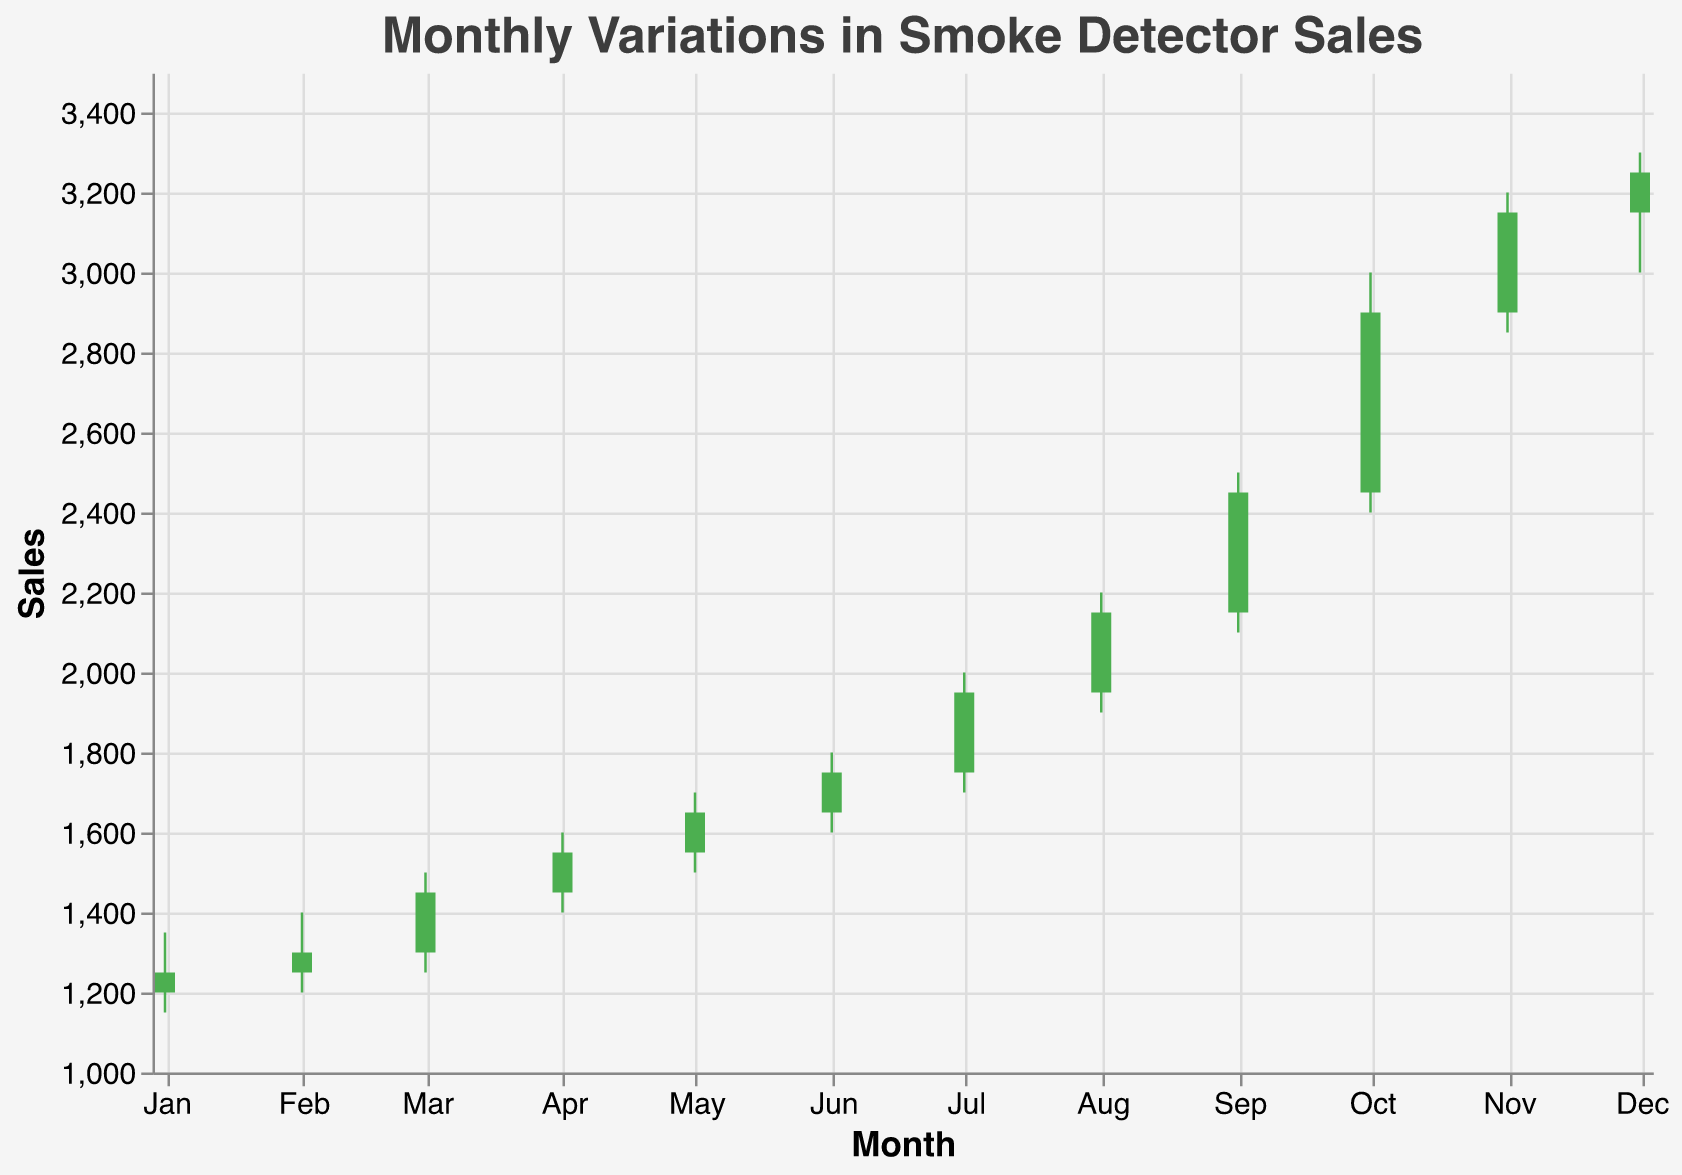What's the title of the chart? The title of the chart is written at the top of the figure and usually describes the overall topic or content being presented.
Answer: Monthly Variations in Smoke Detector Sales How many data points are represented in the chart? Each data point corresponds to a month, starting from January to December. There are 12 months in a year.
Answer: 12 During which month did the sales of smoke detectors peak? The peak sales month in an OHLC chart is identified by the highest "High" value. Based on the data, October has the highest High value of 3000.
Answer: October Which month shows the lowest opening sales value? The lowest opening sales value can be found by observing the "Open" values for each month. January has the lowest opening value of 1200.
Answer: January How much did the sales increase from September to October? To find the increase in sales from September to October, subtract the "Close" value of September from the "Close" value of October. It is 2900 - 2450.
Answer: 450 What was the average closing sales value over the year? To find the average closing value, sum all the "Close" values for each month and divide by the number of months (12). The sum is 1250 + 1300 + 1450 + 1550 + 1650 + 1750 + 1950 + 2150 + 2450 + 2900 + 3150 + 3250 = 27700. Average is 27700/12.
Answer: 2308.33 Which month had the highest volatility in sales, measured by the difference between the High and Low values? Volatility can be measured by taking the difference between the High and Low values for each month. October has the highest difference with 3000 - 2400 = 600.
Answer: October In which months did the sales close higher than they opened? To identify these months, compare the "Open" and "Close" values for each month. Months where Close > Open are shown in green bars. These months are: January, February, March, April, May, June, July, August, September, October, November, December.
Answer: All months What event might be correlating with the observed spike in the sales in October? Since the data shows a significant spike in sales during October, it could be correlated with a seasonal event or campaign, such as Fire Prevention Month which is observed in October.
Answer: Fire Prevention Month 